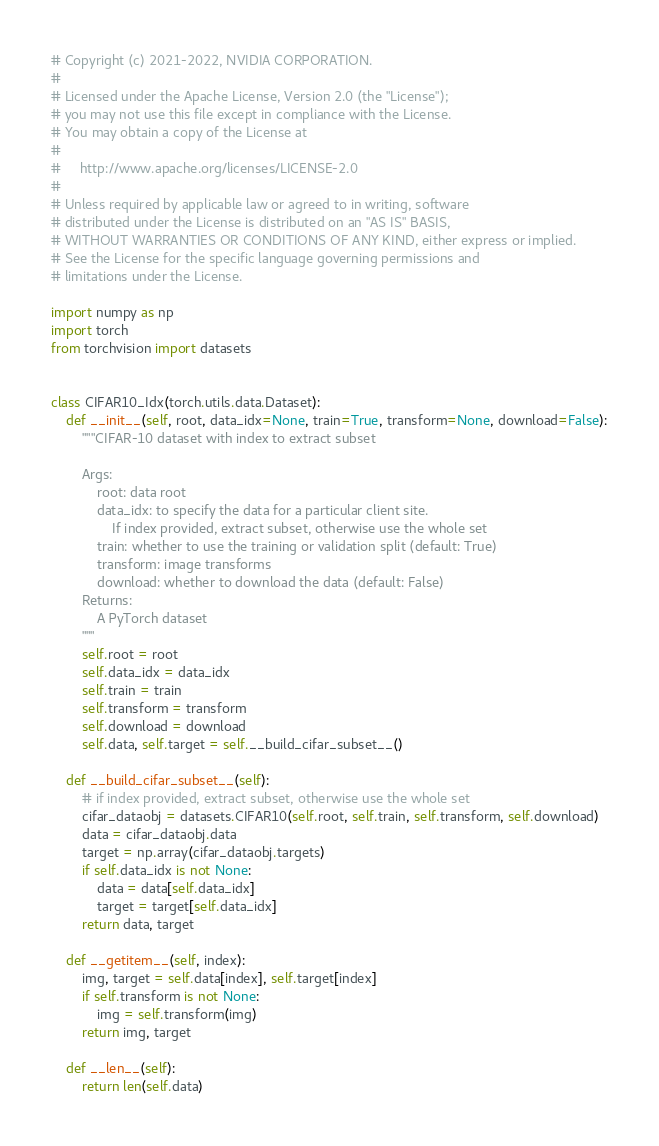Convert code to text. <code><loc_0><loc_0><loc_500><loc_500><_Python_># Copyright (c) 2021-2022, NVIDIA CORPORATION.
#
# Licensed under the Apache License, Version 2.0 (the "License");
# you may not use this file except in compliance with the License.
# You may obtain a copy of the License at
#
#     http://www.apache.org/licenses/LICENSE-2.0
#
# Unless required by applicable law or agreed to in writing, software
# distributed under the License is distributed on an "AS IS" BASIS,
# WITHOUT WARRANTIES OR CONDITIONS OF ANY KIND, either express or implied.
# See the License for the specific language governing permissions and
# limitations under the License.

import numpy as np
import torch
from torchvision import datasets


class CIFAR10_Idx(torch.utils.data.Dataset):
    def __init__(self, root, data_idx=None, train=True, transform=None, download=False):
        """CIFAR-10 dataset with index to extract subset

        Args:
            root: data root
            data_idx: to specify the data for a particular client site.
                If index provided, extract subset, otherwise use the whole set
            train: whether to use the training or validation split (default: True)
            transform: image transforms
            download: whether to download the data (default: False)
        Returns:
            A PyTorch dataset
        """
        self.root = root
        self.data_idx = data_idx
        self.train = train
        self.transform = transform
        self.download = download
        self.data, self.target = self.__build_cifar_subset__()

    def __build_cifar_subset__(self):
        # if index provided, extract subset, otherwise use the whole set
        cifar_dataobj = datasets.CIFAR10(self.root, self.train, self.transform, self.download)
        data = cifar_dataobj.data
        target = np.array(cifar_dataobj.targets)
        if self.data_idx is not None:
            data = data[self.data_idx]
            target = target[self.data_idx]
        return data, target

    def __getitem__(self, index):
        img, target = self.data[index], self.target[index]
        if self.transform is not None:
            img = self.transform(img)
        return img, target

    def __len__(self):
        return len(self.data)
</code> 